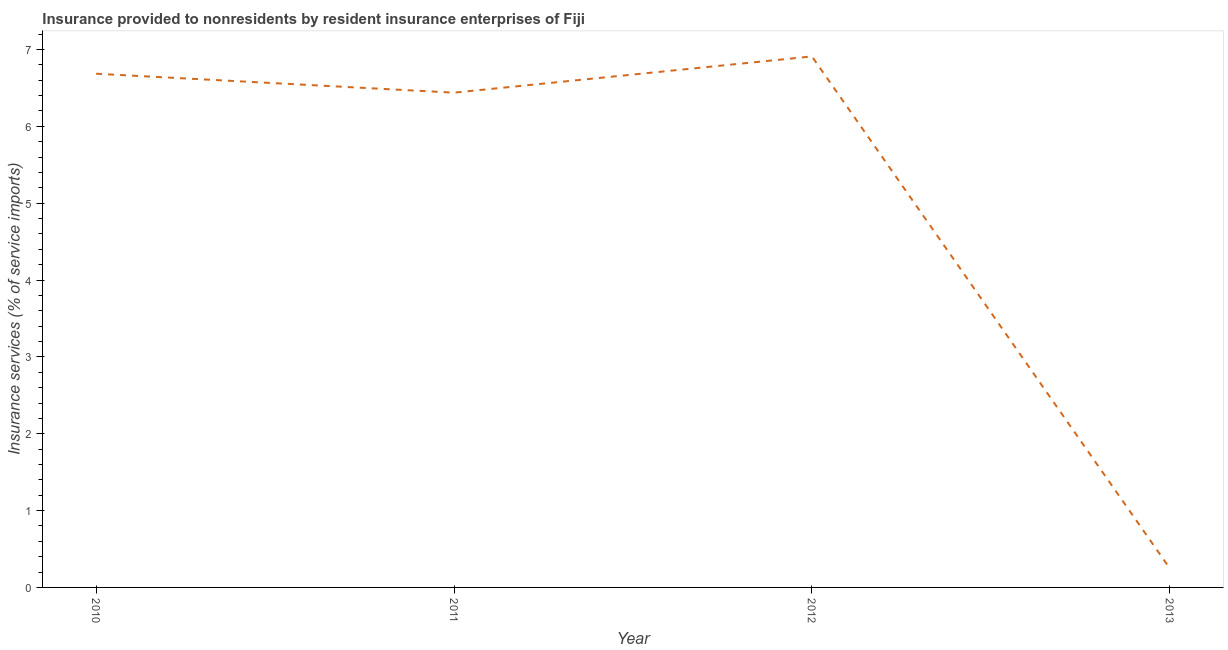What is the insurance and financial services in 2010?
Ensure brevity in your answer.  6.69. Across all years, what is the maximum insurance and financial services?
Your answer should be compact. 6.91. Across all years, what is the minimum insurance and financial services?
Ensure brevity in your answer.  0.25. In which year was the insurance and financial services minimum?
Your response must be concise. 2013. What is the sum of the insurance and financial services?
Give a very brief answer. 20.28. What is the difference between the insurance and financial services in 2010 and 2013?
Provide a succinct answer. 6.44. What is the average insurance and financial services per year?
Provide a succinct answer. 5.07. What is the median insurance and financial services?
Provide a succinct answer. 6.56. What is the ratio of the insurance and financial services in 2011 to that in 2013?
Give a very brief answer. 25.97. Is the insurance and financial services in 2010 less than that in 2011?
Provide a succinct answer. No. Is the difference between the insurance and financial services in 2011 and 2013 greater than the difference between any two years?
Make the answer very short. No. What is the difference between the highest and the second highest insurance and financial services?
Provide a short and direct response. 0.23. Is the sum of the insurance and financial services in 2010 and 2013 greater than the maximum insurance and financial services across all years?
Make the answer very short. Yes. What is the difference between the highest and the lowest insurance and financial services?
Make the answer very short. 6.66. In how many years, is the insurance and financial services greater than the average insurance and financial services taken over all years?
Offer a terse response. 3. What is the difference between two consecutive major ticks on the Y-axis?
Give a very brief answer. 1. Are the values on the major ticks of Y-axis written in scientific E-notation?
Provide a short and direct response. No. What is the title of the graph?
Provide a succinct answer. Insurance provided to nonresidents by resident insurance enterprises of Fiji. What is the label or title of the Y-axis?
Provide a short and direct response. Insurance services (% of service imports). What is the Insurance services (% of service imports) of 2010?
Make the answer very short. 6.69. What is the Insurance services (% of service imports) of 2011?
Keep it short and to the point. 6.44. What is the Insurance services (% of service imports) in 2012?
Your answer should be compact. 6.91. What is the Insurance services (% of service imports) in 2013?
Provide a succinct answer. 0.25. What is the difference between the Insurance services (% of service imports) in 2010 and 2011?
Your answer should be very brief. 0.25. What is the difference between the Insurance services (% of service imports) in 2010 and 2012?
Your answer should be very brief. -0.23. What is the difference between the Insurance services (% of service imports) in 2010 and 2013?
Provide a succinct answer. 6.44. What is the difference between the Insurance services (% of service imports) in 2011 and 2012?
Your response must be concise. -0.47. What is the difference between the Insurance services (% of service imports) in 2011 and 2013?
Give a very brief answer. 6.19. What is the difference between the Insurance services (% of service imports) in 2012 and 2013?
Offer a very short reply. 6.66. What is the ratio of the Insurance services (% of service imports) in 2010 to that in 2011?
Provide a short and direct response. 1.04. What is the ratio of the Insurance services (% of service imports) in 2010 to that in 2013?
Offer a very short reply. 26.96. What is the ratio of the Insurance services (% of service imports) in 2011 to that in 2012?
Keep it short and to the point. 0.93. What is the ratio of the Insurance services (% of service imports) in 2011 to that in 2013?
Offer a very short reply. 25.97. What is the ratio of the Insurance services (% of service imports) in 2012 to that in 2013?
Your answer should be very brief. 27.87. 